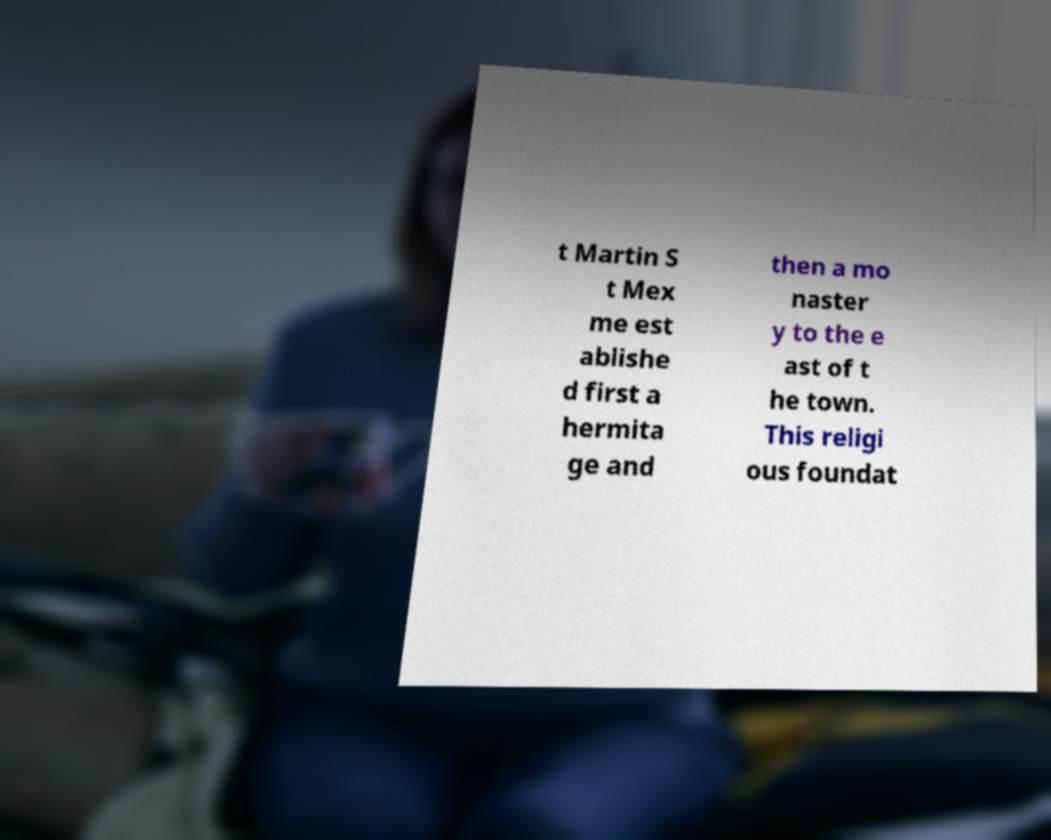Please identify and transcribe the text found in this image. t Martin S t Mex me est ablishe d first a hermita ge and then a mo naster y to the e ast of t he town. This religi ous foundat 